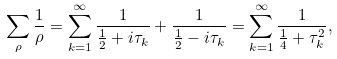<formula> <loc_0><loc_0><loc_500><loc_500>\sum _ { \rho } \frac { 1 } { \rho } = \sum _ { k = 1 } ^ { \infty } \frac { 1 } { \frac { 1 } { 2 } + i \tau _ { k } } + \frac { 1 } { \frac { 1 } { 2 } - i \tau _ { k } } = \sum _ { k = 1 } ^ { \infty } \frac { 1 } { \frac { 1 } { 4 } + \tau _ { k } ^ { 2 } } ,</formula> 